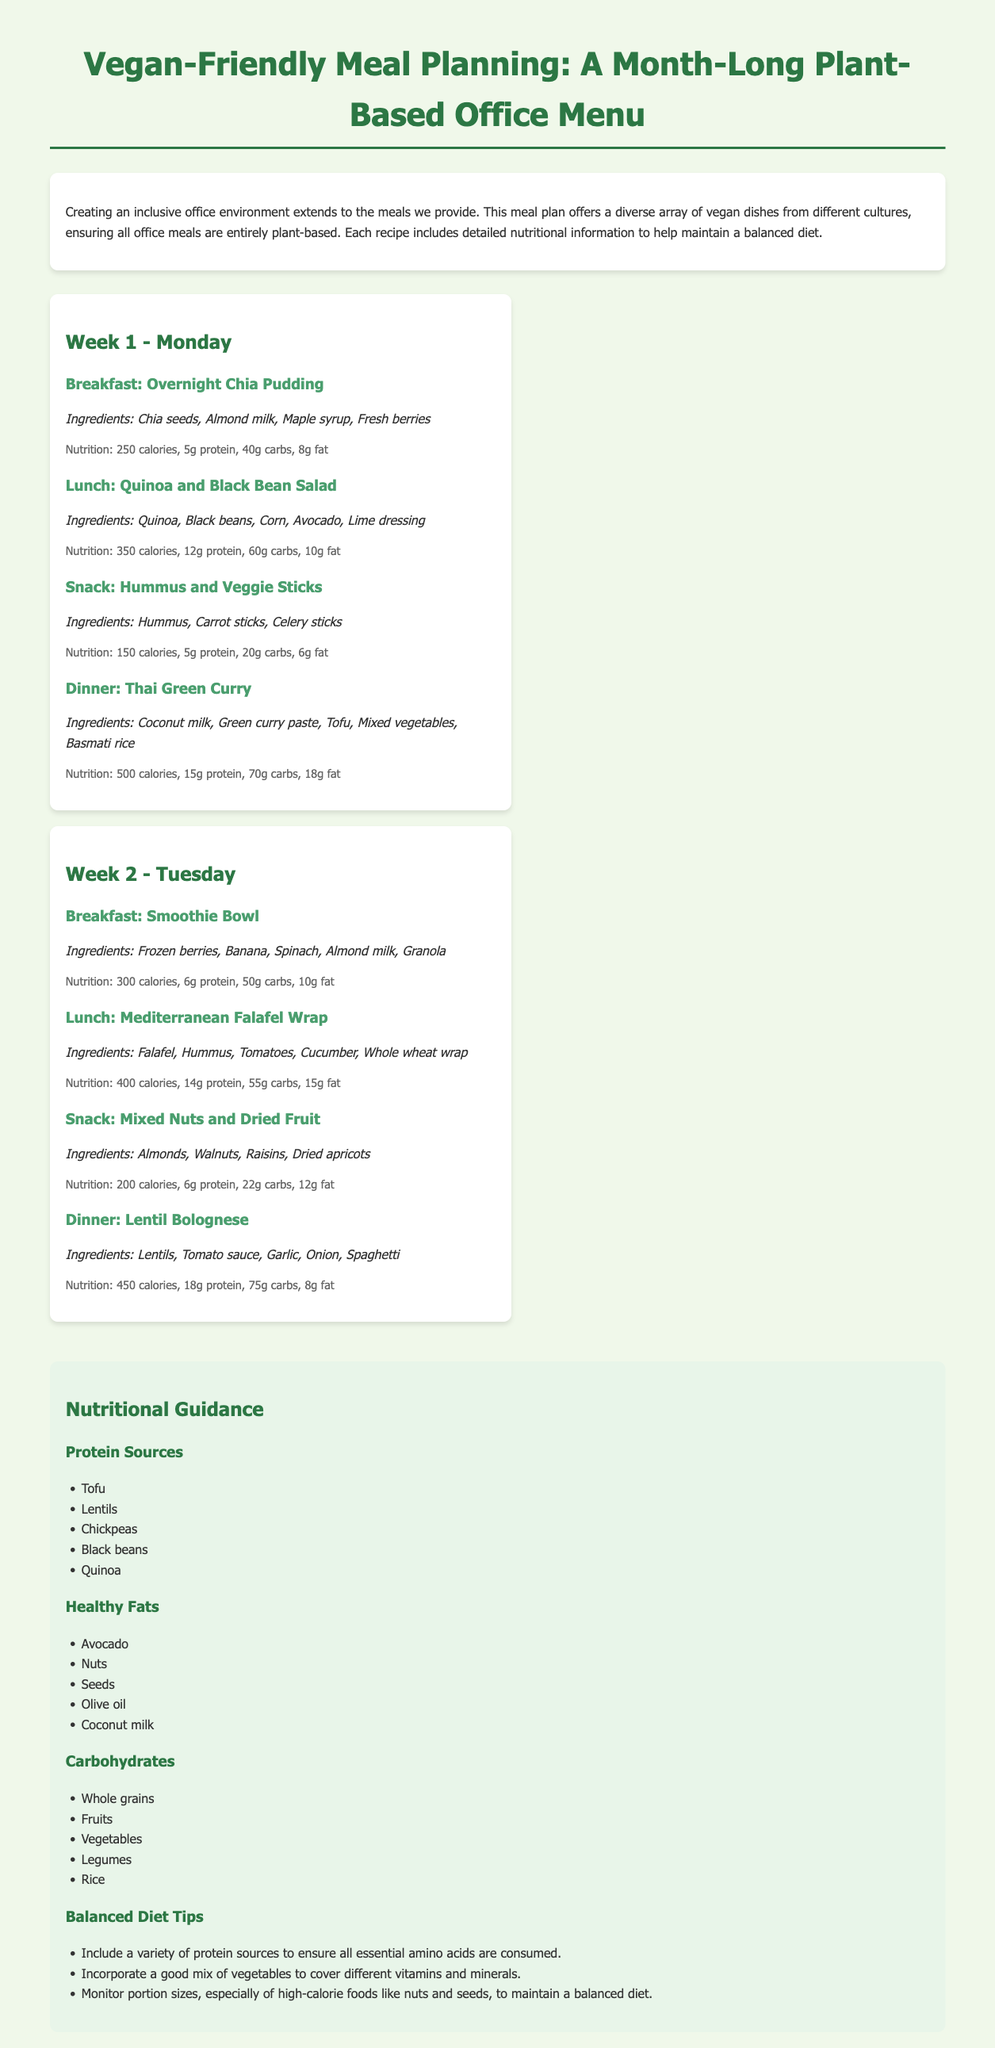What is the total number of meals provided in the meal plan? The document outlines meals for four days (two for each of the first two weeks), and each day has four meals (breakfast, lunch, snack, dinner), leading to a total of 16 meals.
Answer: 16 meals What is the main ingredient in the Thai Green Curry? The Thai Green Curry recipe lists several ingredients, with "Tofu" being a major component.
Answer: Tofu What is the calorie count for the Quinoa and Black Bean Salad? The Quinoa and Black Bean Salad is detailed in the meal plan with its nutritional value showing a calorie count of 350.
Answer: 350 calories What cultural cuisine is featured in the Mediterranean Falafel Wrap? The Mediterranean Falafel Wrap identifies its cultural origin, which is Mediterranean cuisine.
Answer: Mediterranean How many grams of protein are in the Lentil Bolognese? The nutritional information states that the Lentil Bolognese contains 18 grams of protein.
Answer: 18g protein What type of meal is listed for Week 1 - Monday? The meals listed include breakfast, lunch, snack, and dinner, so any of these can be considered, but the document specifically mentions "Overnight Chia Pudding" as breakfast.
Answer: Breakfast What are two healthy fat sources mentioned in the nutritional guide? The nutritional guide lists "Avocado" and "Nuts" among other healthy fat sources, demonstrating options for healthy fats.
Answer: Avocado, Nuts Which cuisine is represented in the dinner for Week 2 - Tuesday? The dinner for Week 2 - Tuesday is "Lentil Bolognese," which is an Italian-inspired dish.
Answer: Italian How many grams of carbs does the Overnight Chia Pudding have? The nutritional breakdown of the Overnight Chia Pudding shows it has 40 grams of carbohydrates per serving.
Answer: 40g carbs 